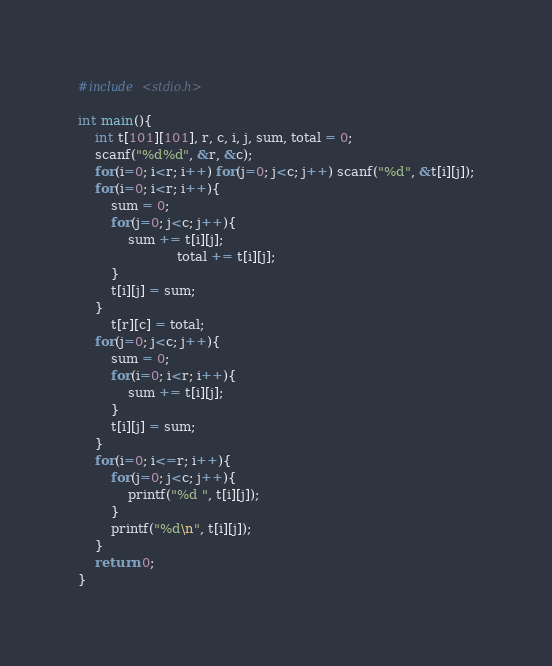<code> <loc_0><loc_0><loc_500><loc_500><_C_>#include <stdio.h>

int main(){
    int t[101][101], r, c, i, j, sum, total = 0;
    scanf("%d%d", &r, &c);
    for(i=0; i<r; i++) for(j=0; j<c; j++) scanf("%d", &t[i][j]);
    for(i=0; i<r; i++){
        sum = 0;
        for(j=0; j<c; j++){
            sum += t[i][j];
                        total += t[i][j];
        }
        t[i][j] = sum;
    }
        t[r][c] = total;
    for(j=0; j<c; j++){
        sum = 0;
        for(i=0; i<r; i++){
            sum += t[i][j];
        }
        t[i][j] = sum;
    }
    for(i=0; i<=r; i++){
        for(j=0; j<c; j++){
            printf("%d ", t[i][j]);
        }
        printf("%d\n", t[i][j]);
    }
    return 0;
}
</code> 